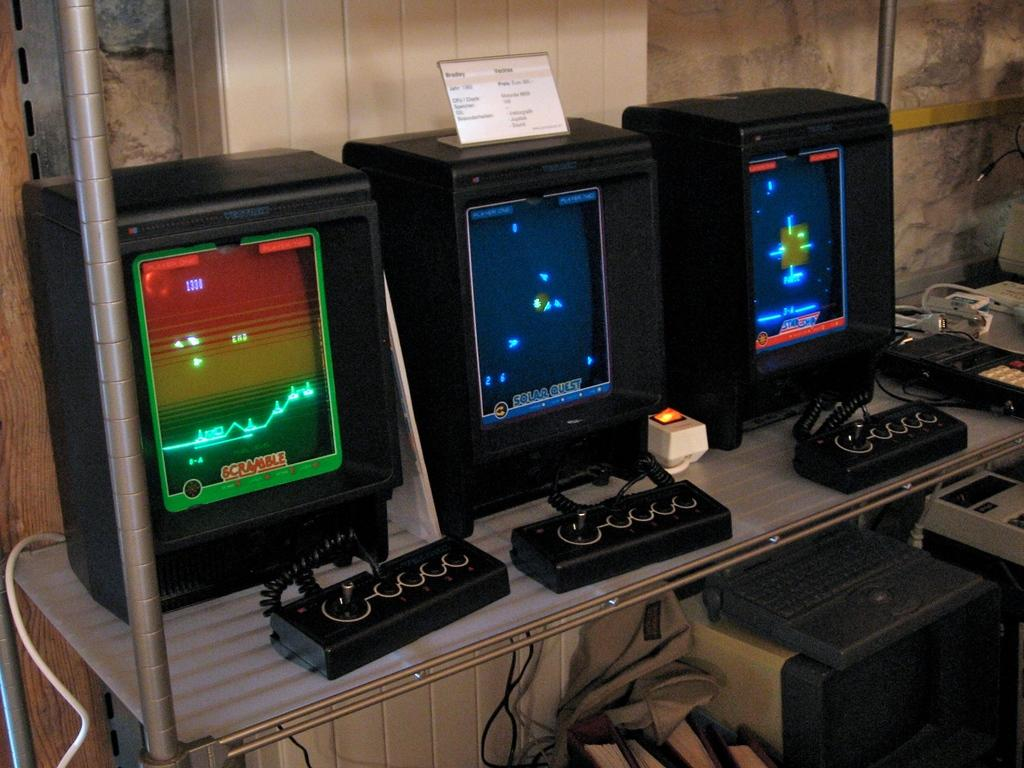<image>
Provide a brief description of the given image. An old style game console on the left has a screen with scramble at the bottom 